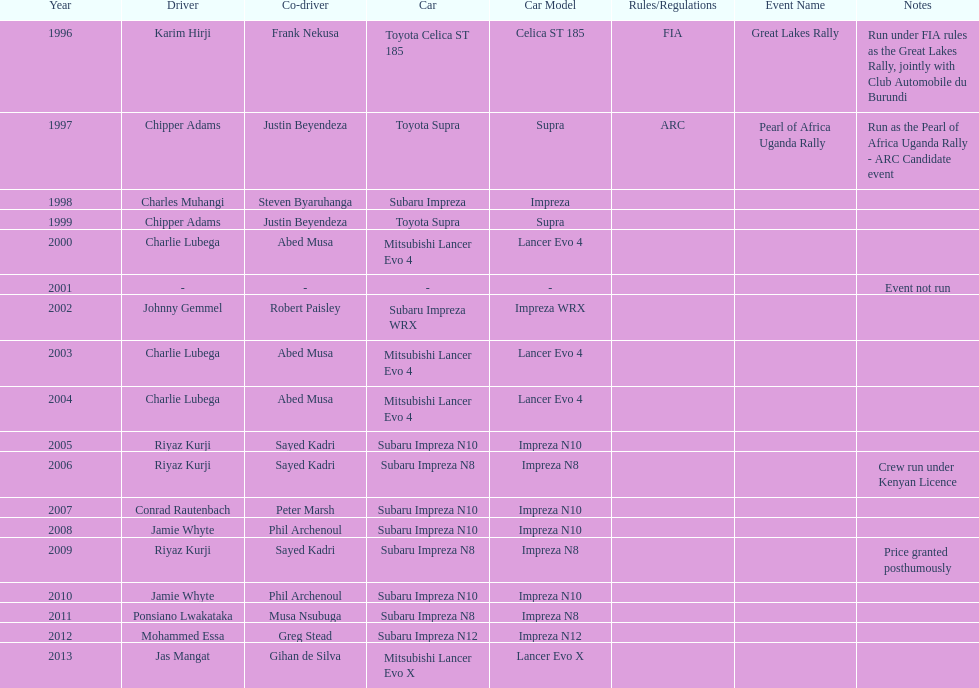How many times was charlie lubega a driver? 3. 